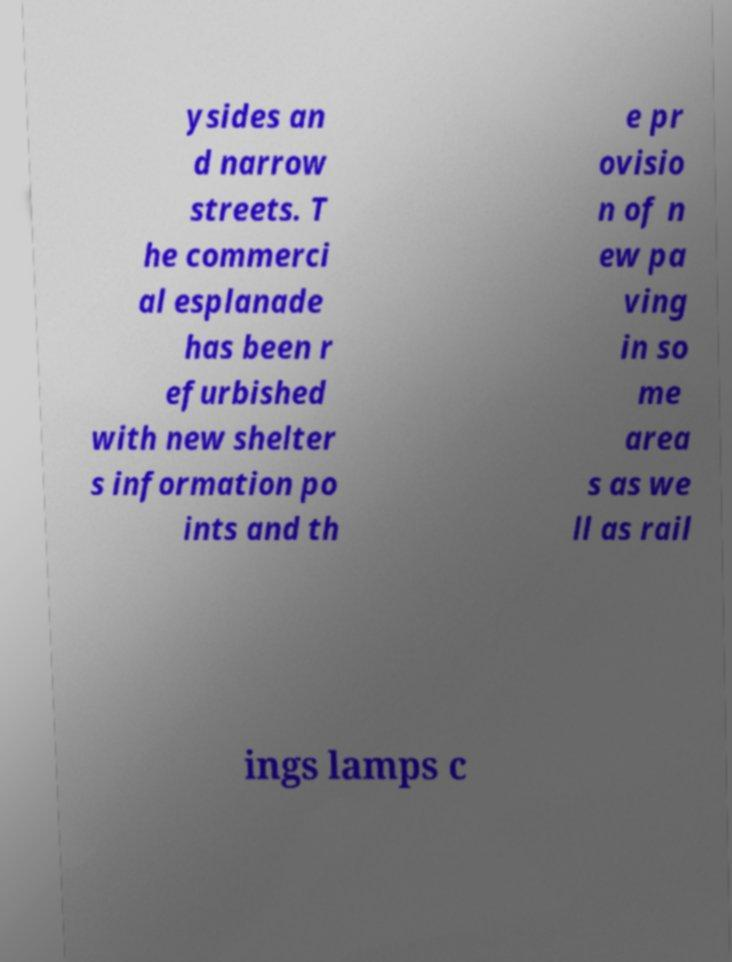Can you read and provide the text displayed in the image?This photo seems to have some interesting text. Can you extract and type it out for me? ysides an d narrow streets. T he commerci al esplanade has been r efurbished with new shelter s information po ints and th e pr ovisio n of n ew pa ving in so me area s as we ll as rail ings lamps c 